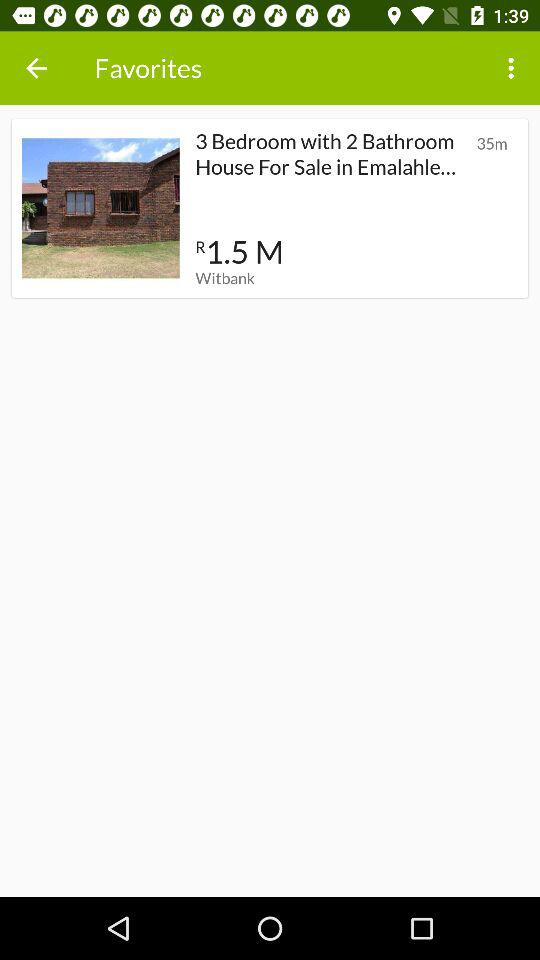How many more bedrooms does the house have than bathrooms?
Answer the question using a single word or phrase. 1 